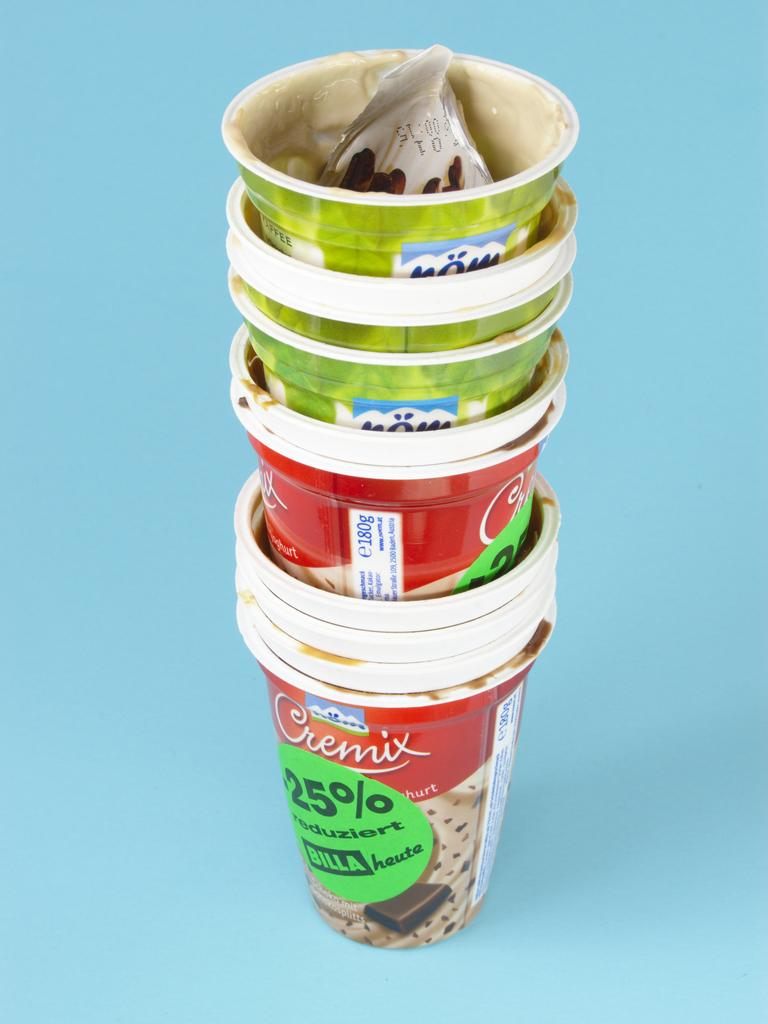What type of glasses are visible in the image? There are plastic glasses in the image. Can you describe the surface on which the plastic glasses are placed? The plastic glasses are on a blue surface. Is there a fight happening between the plastic glasses in the image? No, there is no fight happening between the plastic glasses in the image. Where might the plastic glasses be located if they were in a park? The provided facts do not give any information about the location of the plastic glasses, so it cannot be determined if they might be in a park. 